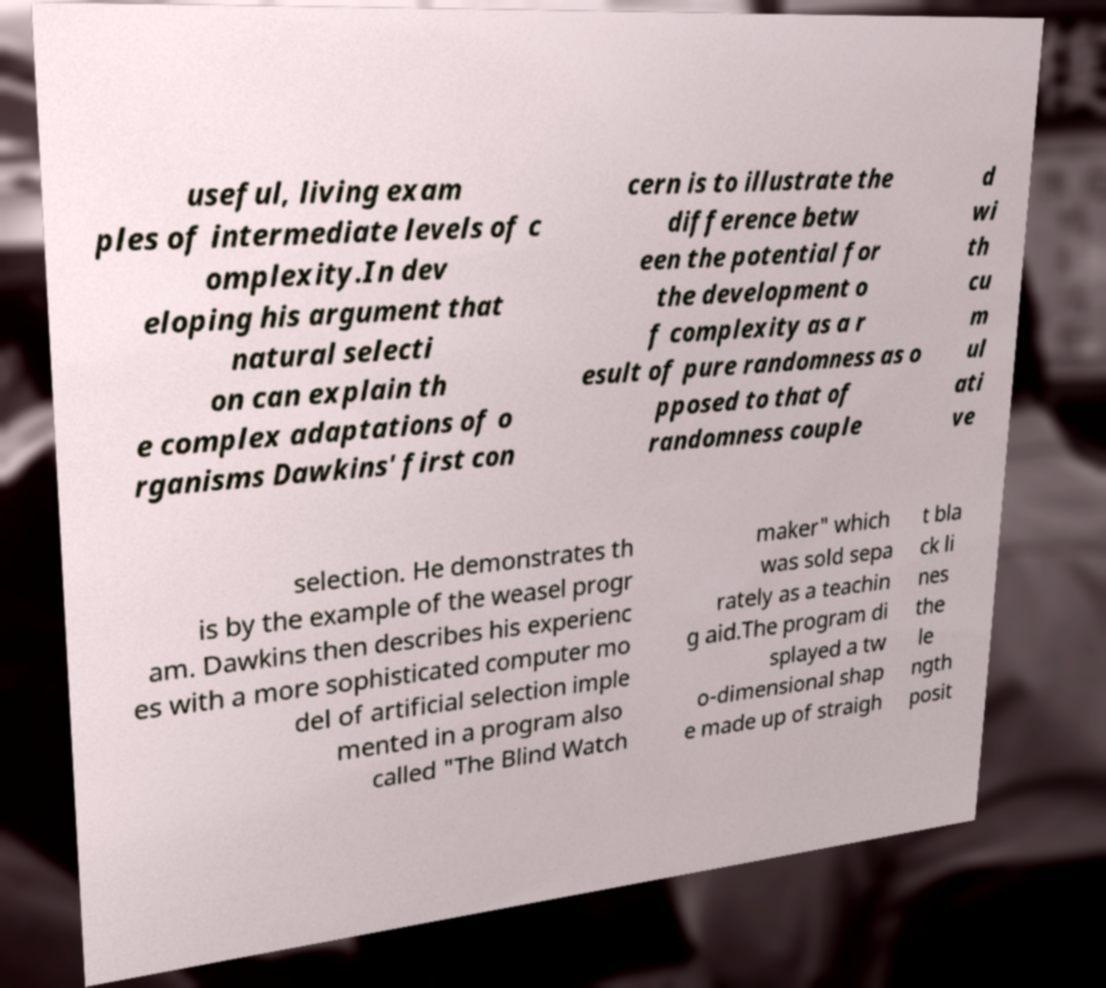Please identify and transcribe the text found in this image. useful, living exam ples of intermediate levels of c omplexity.In dev eloping his argument that natural selecti on can explain th e complex adaptations of o rganisms Dawkins' first con cern is to illustrate the difference betw een the potential for the development o f complexity as a r esult of pure randomness as o pposed to that of randomness couple d wi th cu m ul ati ve selection. He demonstrates th is by the example of the weasel progr am. Dawkins then describes his experienc es with a more sophisticated computer mo del of artificial selection imple mented in a program also called "The Blind Watch maker" which was sold sepa rately as a teachin g aid.The program di splayed a tw o-dimensional shap e made up of straigh t bla ck li nes the le ngth posit 